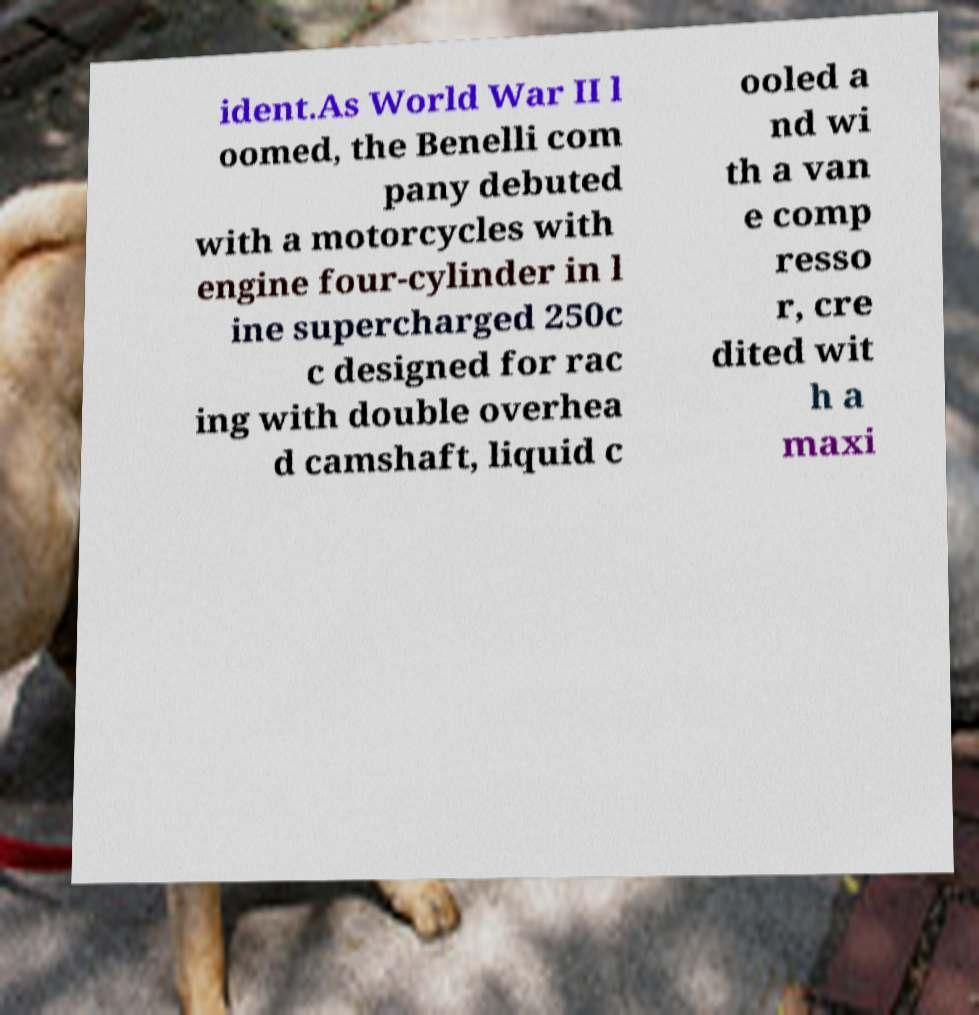Please read and relay the text visible in this image. What does it say? ident.As World War II l oomed, the Benelli com pany debuted with a motorcycles with engine four-cylinder in l ine supercharged 250c c designed for rac ing with double overhea d camshaft, liquid c ooled a nd wi th a van e comp resso r, cre dited wit h a maxi 